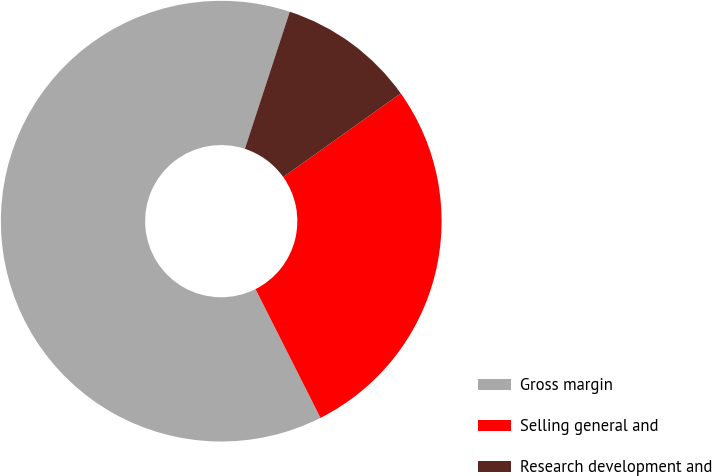Convert chart to OTSL. <chart><loc_0><loc_0><loc_500><loc_500><pie_chart><fcel>Gross margin<fcel>Selling general and<fcel>Research development and<nl><fcel>62.47%<fcel>27.41%<fcel>10.12%<nl></chart> 